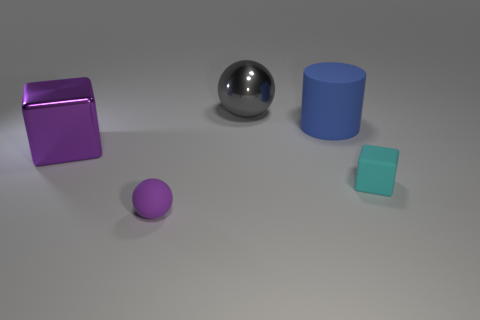How big is the blue matte thing?
Make the answer very short. Large. There is a purple thing that is the same shape as the small cyan object; what size is it?
Ensure brevity in your answer.  Large. How many big things are gray metal objects or spheres?
Provide a succinct answer. 1. Are the cube that is on the right side of the gray ball and the purple cube that is to the left of the large gray shiny object made of the same material?
Your answer should be very brief. No. What is the material of the ball in front of the shiny ball?
Make the answer very short. Rubber. What number of metal objects are blue cylinders or gray spheres?
Provide a short and direct response. 1. There is a big metallic object that is to the right of the big thing that is in front of the large blue rubber cylinder; what color is it?
Keep it short and to the point. Gray. Does the large block have the same material as the tiny object right of the gray metal sphere?
Offer a terse response. No. What is the color of the large object that is to the left of the gray shiny sphere that is on the left side of the large blue rubber thing behind the tiny purple thing?
Ensure brevity in your answer.  Purple. Is there anything else that has the same shape as the large blue thing?
Offer a very short reply. No. 